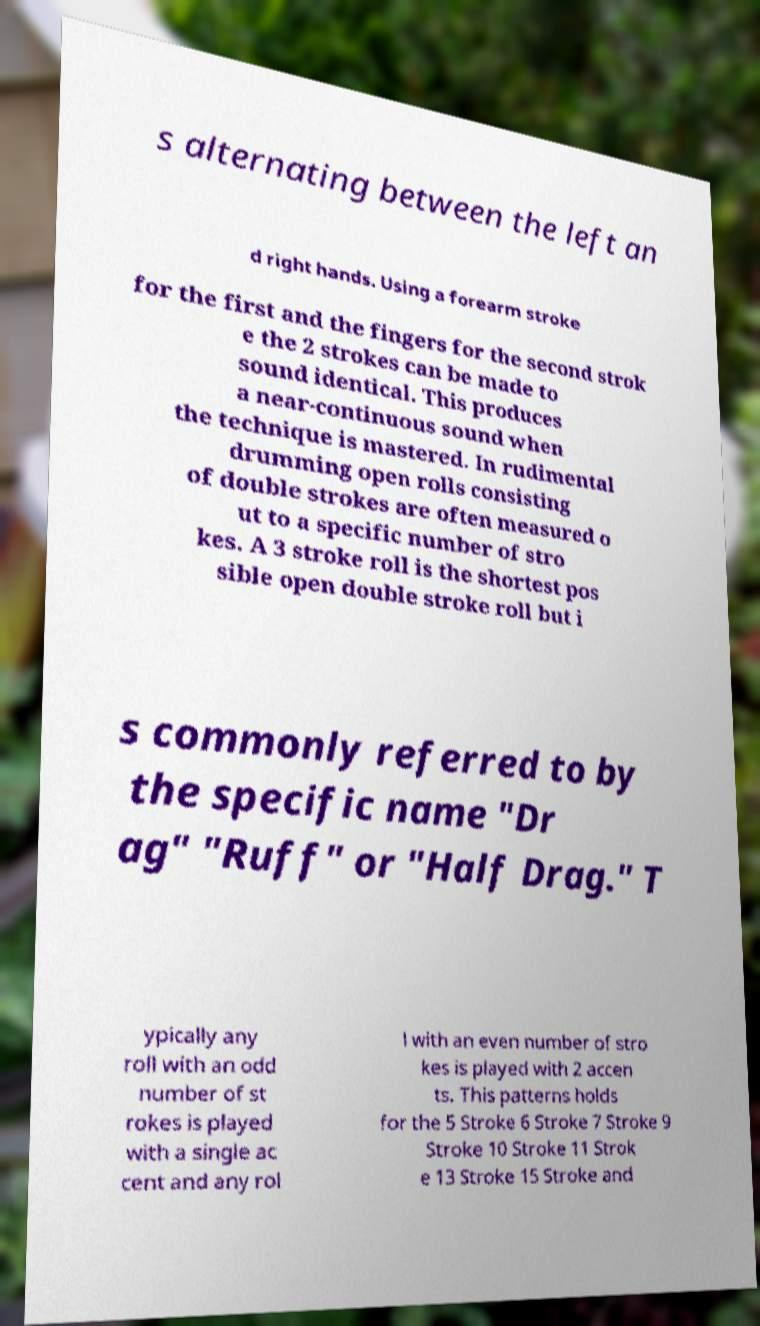Could you assist in decoding the text presented in this image and type it out clearly? s alternating between the left an d right hands. Using a forearm stroke for the first and the fingers for the second strok e the 2 strokes can be made to sound identical. This produces a near-continuous sound when the technique is mastered. In rudimental drumming open rolls consisting of double strokes are often measured o ut to a specific number of stro kes. A 3 stroke roll is the shortest pos sible open double stroke roll but i s commonly referred to by the specific name "Dr ag" "Ruff" or "Half Drag." T ypically any roll with an odd number of st rokes is played with a single ac cent and any rol l with an even number of stro kes is played with 2 accen ts. This patterns holds for the 5 Stroke 6 Stroke 7 Stroke 9 Stroke 10 Stroke 11 Strok e 13 Stroke 15 Stroke and 